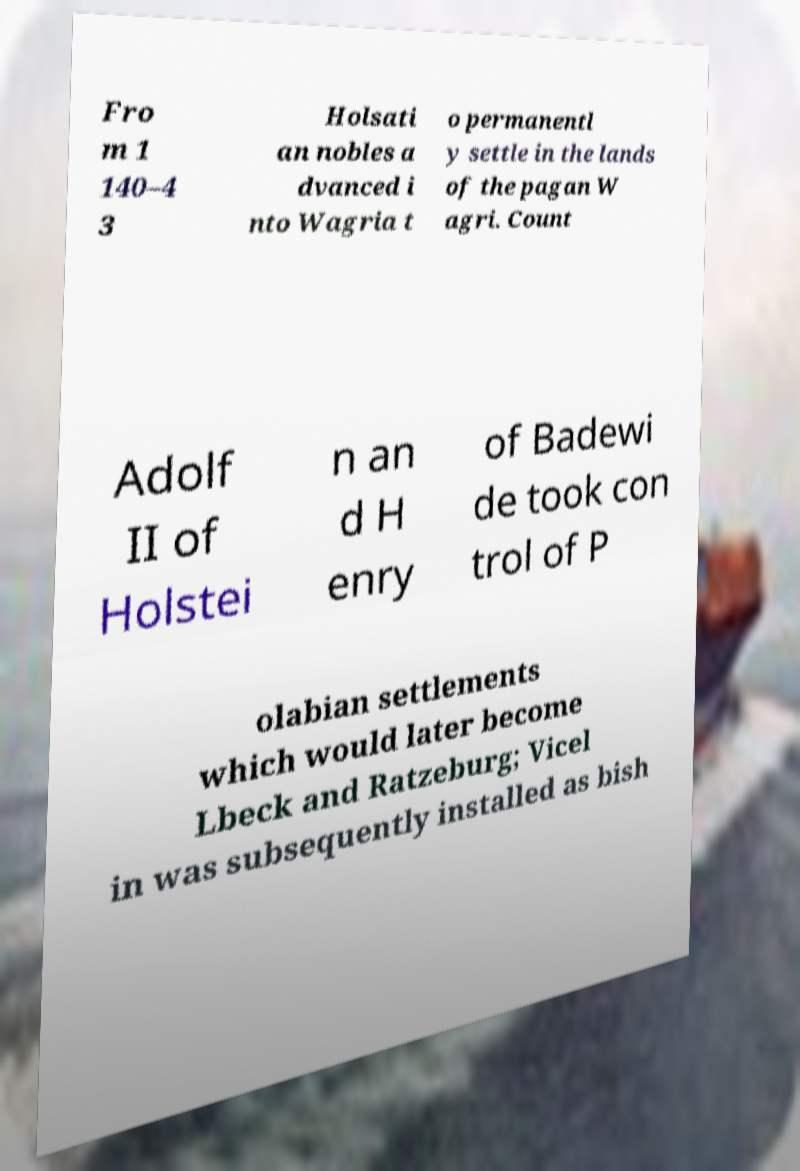Could you extract and type out the text from this image? Fro m 1 140–4 3 Holsati an nobles a dvanced i nto Wagria t o permanentl y settle in the lands of the pagan W agri. Count Adolf II of Holstei n an d H enry of Badewi de took con trol of P olabian settlements which would later become Lbeck and Ratzeburg; Vicel in was subsequently installed as bish 